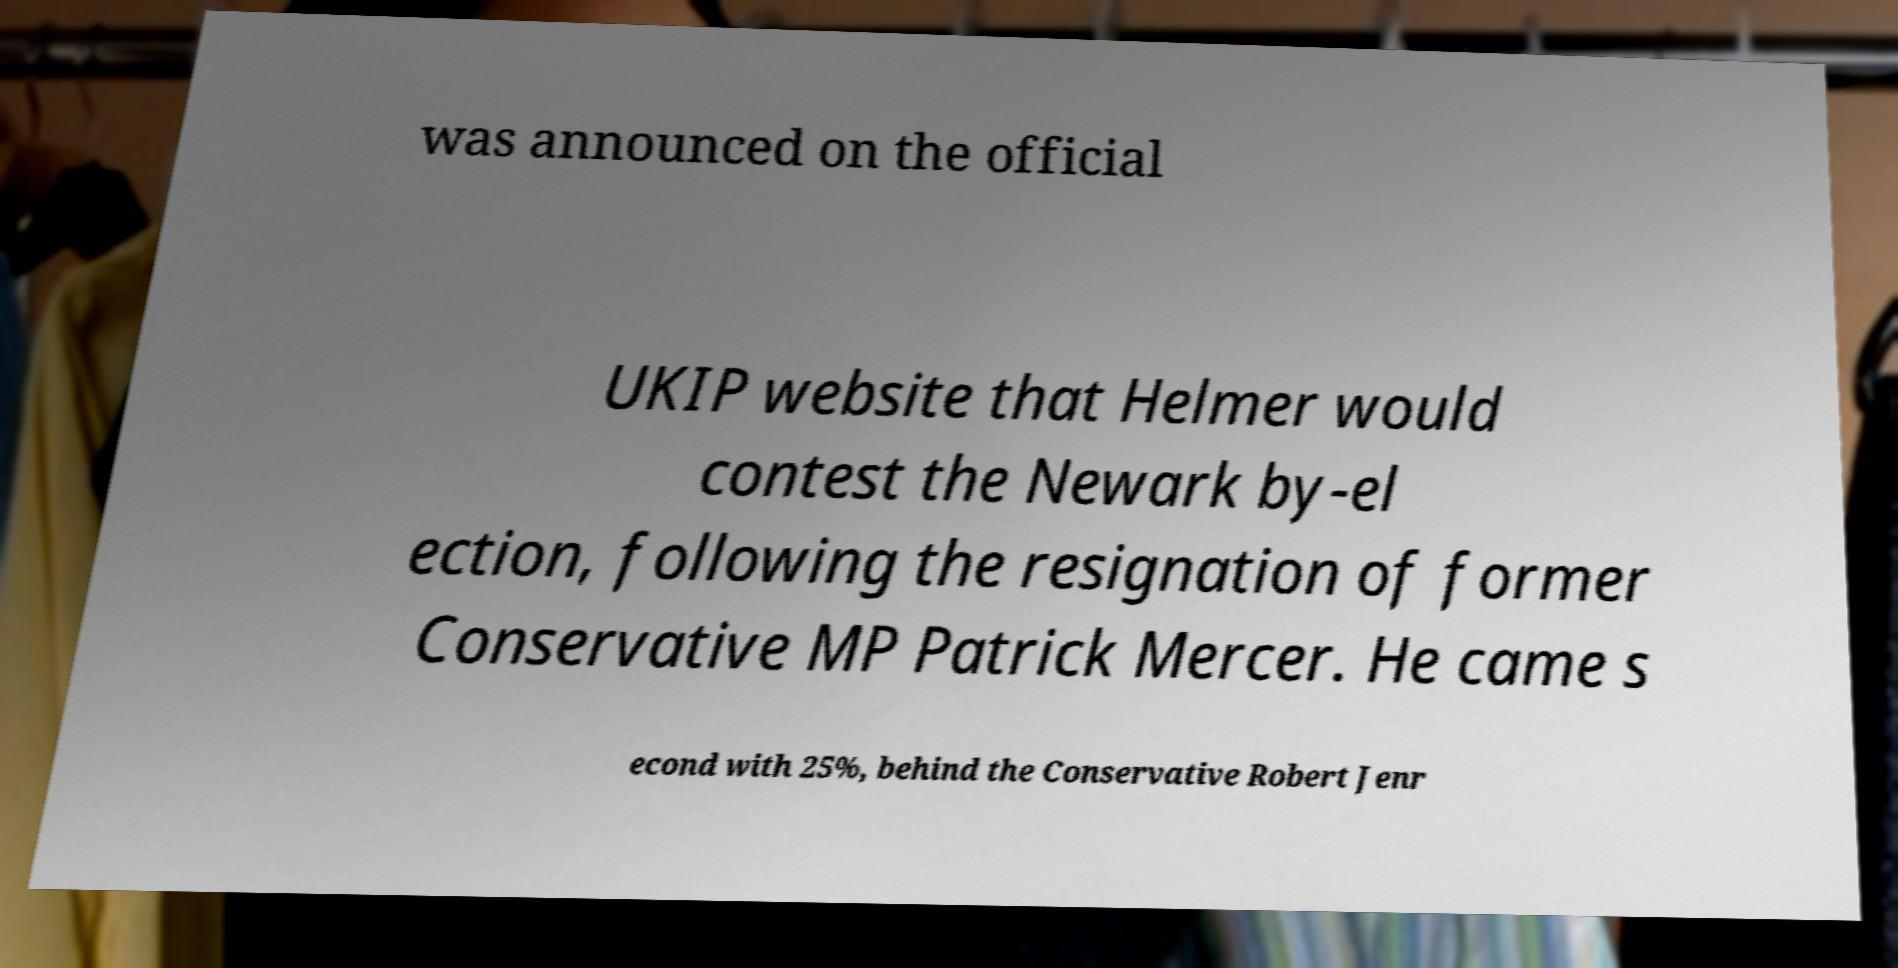Could you assist in decoding the text presented in this image and type it out clearly? was announced on the official UKIP website that Helmer would contest the Newark by-el ection, following the resignation of former Conservative MP Patrick Mercer. He came s econd with 25%, behind the Conservative Robert Jenr 